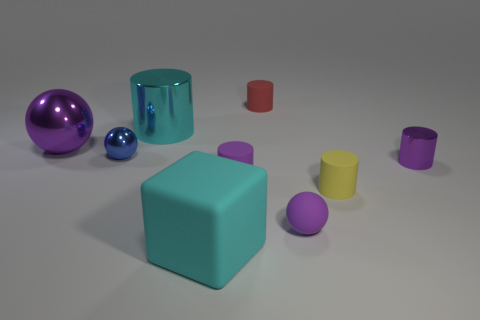There is a purple ball to the right of the big cyan cylinder; what is its material?
Your answer should be compact. Rubber. Do the cyan metal cylinder and the yellow cylinder have the same size?
Your response must be concise. No. How many other things are there of the same size as the cyan rubber block?
Provide a short and direct response. 2. Does the big rubber object have the same color as the large shiny cylinder?
Your answer should be very brief. Yes. There is a tiny shiny object that is to the right of the rubber thing behind the purple shiny thing to the left of the large cylinder; what shape is it?
Give a very brief answer. Cylinder. How many things are things to the right of the large cylinder or metallic things that are right of the large cyan matte thing?
Your answer should be very brief. 6. There is a purple metal thing that is right of the big cyan object that is behind the big purple metal ball; what size is it?
Your answer should be very brief. Small. There is a metal cylinder that is on the right side of the cyan metallic cylinder; is it the same color as the big ball?
Ensure brevity in your answer.  Yes. Is there a large cyan metal object that has the same shape as the tiny blue shiny object?
Provide a succinct answer. No. There is another metal cylinder that is the same size as the red cylinder; what color is it?
Provide a succinct answer. Purple. 